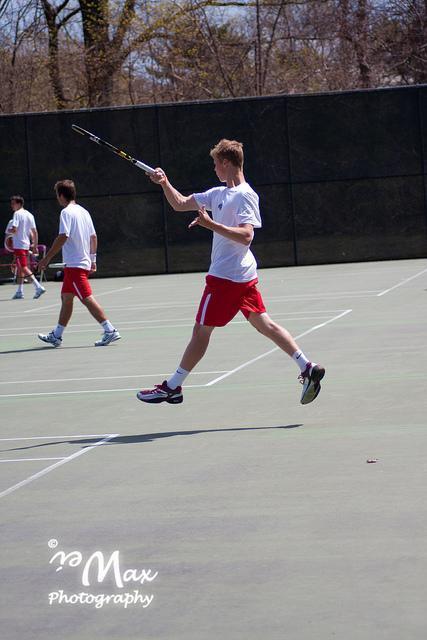How many people are in the picture?
Give a very brief answer. 2. How many black cups are there?
Give a very brief answer. 0. 